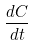<formula> <loc_0><loc_0><loc_500><loc_500>\frac { d C } { d t }</formula> 